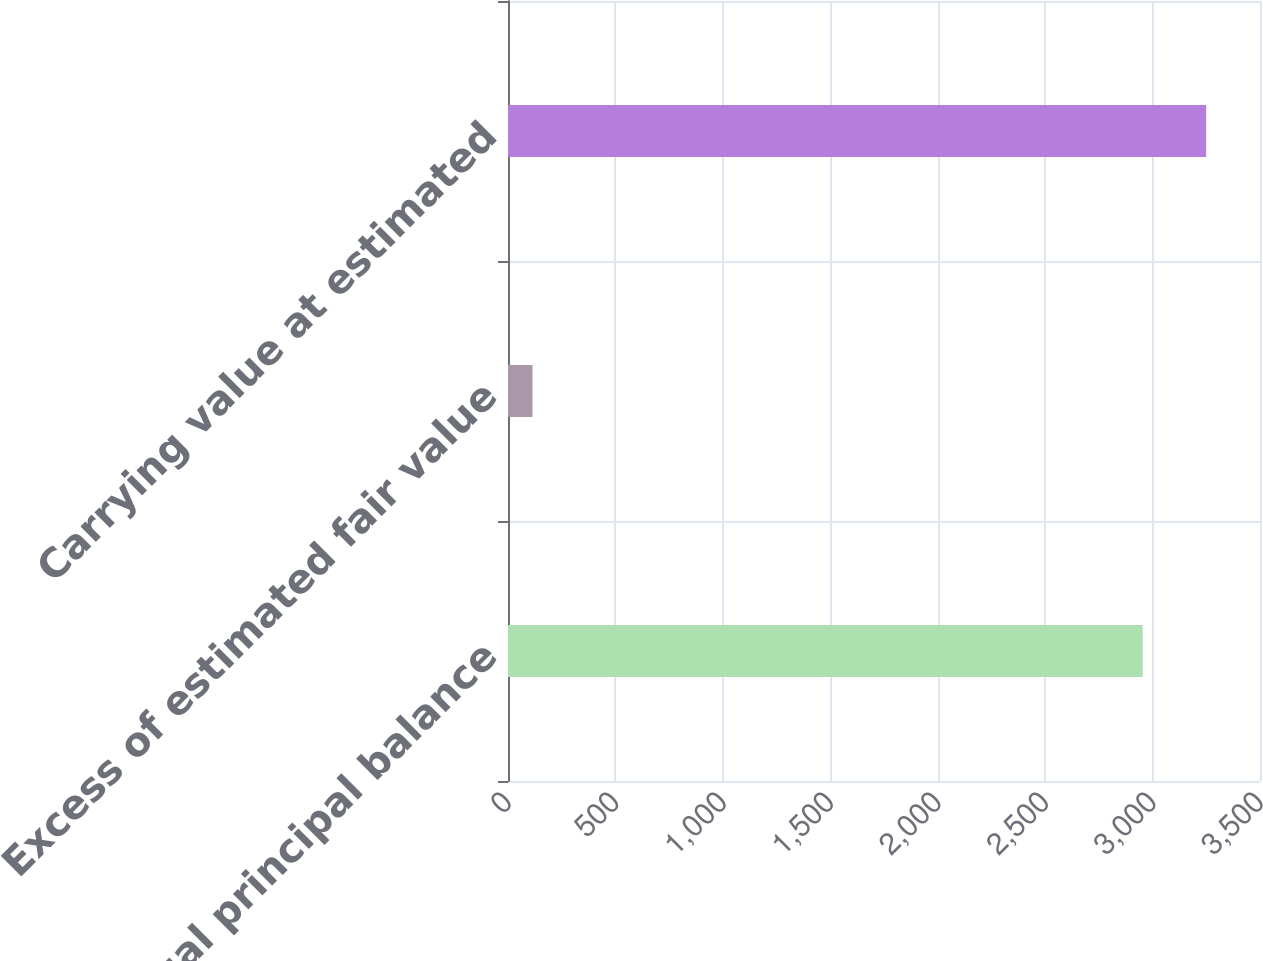<chart> <loc_0><loc_0><loc_500><loc_500><bar_chart><fcel>Contractual principal balance<fcel>Excess of estimated fair value<fcel>Carrying value at estimated<nl><fcel>2954<fcel>114<fcel>3249.4<nl></chart> 